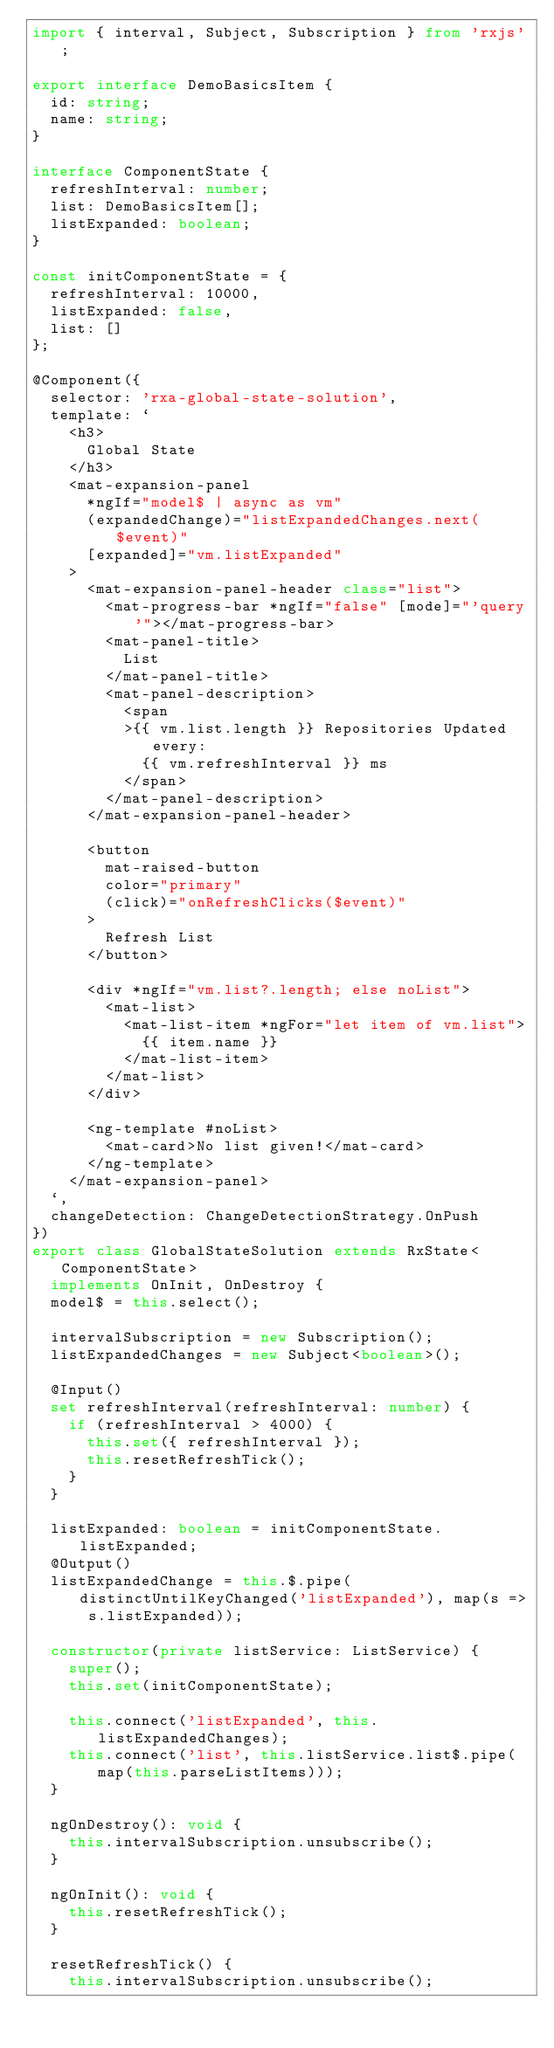<code> <loc_0><loc_0><loc_500><loc_500><_TypeScript_>import { interval, Subject, Subscription } from 'rxjs';

export interface DemoBasicsItem {
  id: string;
  name: string;
}

interface ComponentState {
  refreshInterval: number;
  list: DemoBasicsItem[];
  listExpanded: boolean;
}

const initComponentState = {
  refreshInterval: 10000,
  listExpanded: false,
  list: []
};

@Component({
  selector: 'rxa-global-state-solution',
  template: `
    <h3>
      Global State
    </h3>
    <mat-expansion-panel
      *ngIf="model$ | async as vm"
      (expandedChange)="listExpandedChanges.next($event)"
      [expanded]="vm.listExpanded"
    >
      <mat-expansion-panel-header class="list">
        <mat-progress-bar *ngIf="false" [mode]="'query'"></mat-progress-bar>
        <mat-panel-title>
          List
        </mat-panel-title>
        <mat-panel-description>
          <span
          >{{ vm.list.length }} Repositories Updated every:
            {{ vm.refreshInterval }} ms
          </span>
        </mat-panel-description>
      </mat-expansion-panel-header>

      <button
        mat-raised-button
        color="primary"
        (click)="onRefreshClicks($event)"
      >
        Refresh List
      </button>

      <div *ngIf="vm.list?.length; else noList">
        <mat-list>
          <mat-list-item *ngFor="let item of vm.list">
            {{ item.name }}
          </mat-list-item>
        </mat-list>
      </div>

      <ng-template #noList>
        <mat-card>No list given!</mat-card>
      </ng-template>
    </mat-expansion-panel>
  `,
  changeDetection: ChangeDetectionStrategy.OnPush
})
export class GlobalStateSolution extends RxState<ComponentState>
  implements OnInit, OnDestroy {
  model$ = this.select();

  intervalSubscription = new Subscription();
  listExpandedChanges = new Subject<boolean>();

  @Input()
  set refreshInterval(refreshInterval: number) {
    if (refreshInterval > 4000) {
      this.set({ refreshInterval });
      this.resetRefreshTick();
    }
  }

  listExpanded: boolean = initComponentState.listExpanded;
  @Output()
  listExpandedChange = this.$.pipe(distinctUntilKeyChanged('listExpanded'), map(s => s.listExpanded));

  constructor(private listService: ListService) {
    super();
    this.set(initComponentState);

    this.connect('listExpanded', this.listExpandedChanges);
    this.connect('list', this.listService.list$.pipe(map(this.parseListItems)));
  }

  ngOnDestroy(): void {
    this.intervalSubscription.unsubscribe();
  }

  ngOnInit(): void {
    this.resetRefreshTick();
  }

  resetRefreshTick() {
    this.intervalSubscription.unsubscribe();</code> 